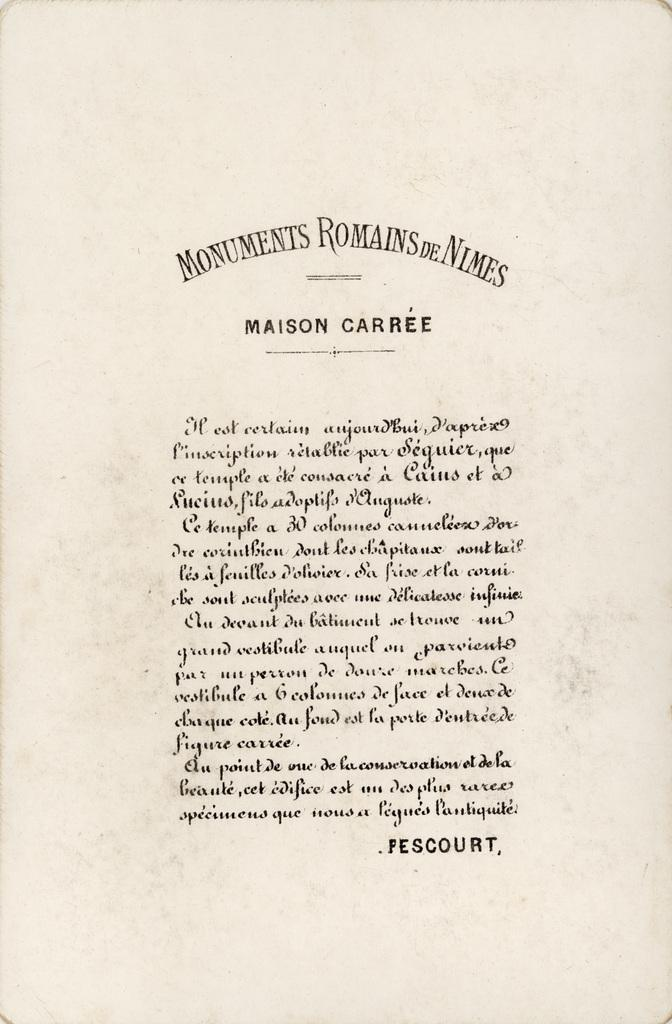<image>
Share a concise interpretation of the image provided. A page from a book has the name Pescourt at the bottom. 